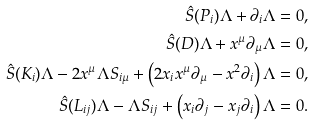Convert formula to latex. <formula><loc_0><loc_0><loc_500><loc_500>\hat { S } ( P _ { i } ) \Lambda + \partial _ { i } \Lambda & = 0 , \\ \hat { S } ( D ) \Lambda + x ^ { \mu } \partial _ { \mu } \Lambda & = 0 , \\ \hat { S } ( K _ { i } ) \Lambda - 2 x ^ { \mu } \Lambda S _ { i \mu } + \left ( 2 x _ { i } x ^ { \mu } \partial _ { \mu } - x ^ { 2 } \partial _ { i } \right ) \Lambda & = 0 , \\ \hat { S } ( L _ { i j } ) \Lambda - \Lambda S _ { i j } + \left ( x _ { i } \partial _ { j } - x _ { j } \partial _ { i } \right ) \Lambda & = 0 .</formula> 